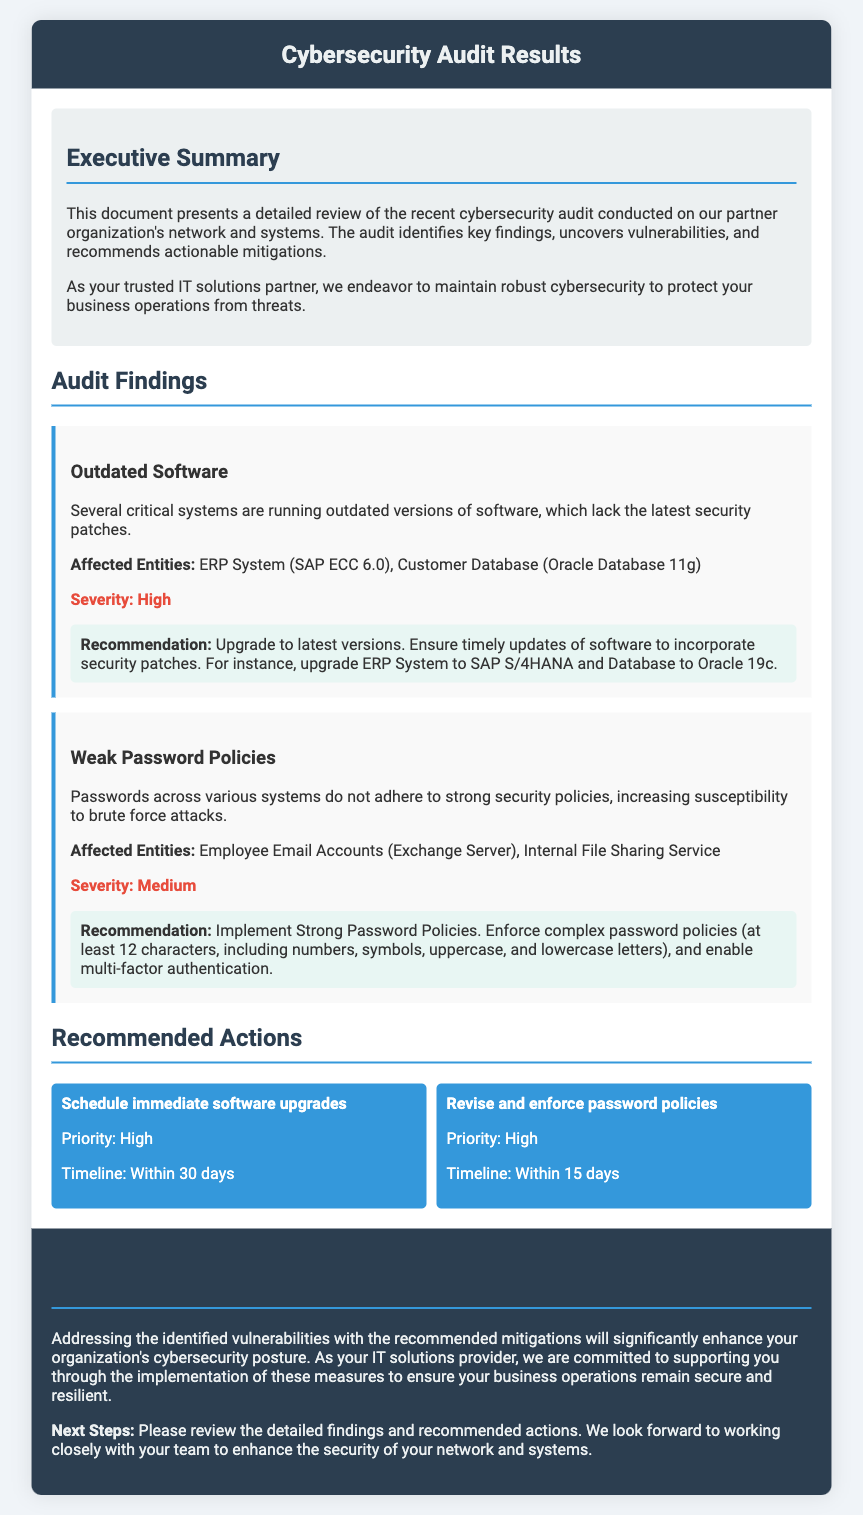what is the title of the document? The title of the document is specified at the top of the rendered content in the header section.
Answer: Cybersecurity Audit Results how many high severity findings are mentioned? The document lists two findings under different severity levels, with one being high severity.
Answer: 1 which systems are mentioned as running outdated software? Affected systems are specifically noted in the findings section regarding outdated software.
Answer: ERP System (SAP ECC 6.0), Customer Database (Oracle Database 11g) what is the recommended action for outdated software? The document provides a specific recommendation for addressing outdated software under the findings section.
Answer: Upgrade to latest versions what is the timeline for revising and enforcing password policies? The timeline for this action is present within the recommended actions section.
Answer: Within 15 days what is the severity level of weak password policies? Severity levels can be found listed next to each finding in the document.
Answer: Medium what should be implemented according to the recommendation on weak password policies? Specific recommendations for weak password policies are provided in the findings section.
Answer: Strong Password Policies what does the conclusion emphasize regarding vulnerabilities? The conclusion provides a summary of the overall importance of addressing vulnerabilities after reviewing the findings.
Answer: Enhancing cybersecurity posture 